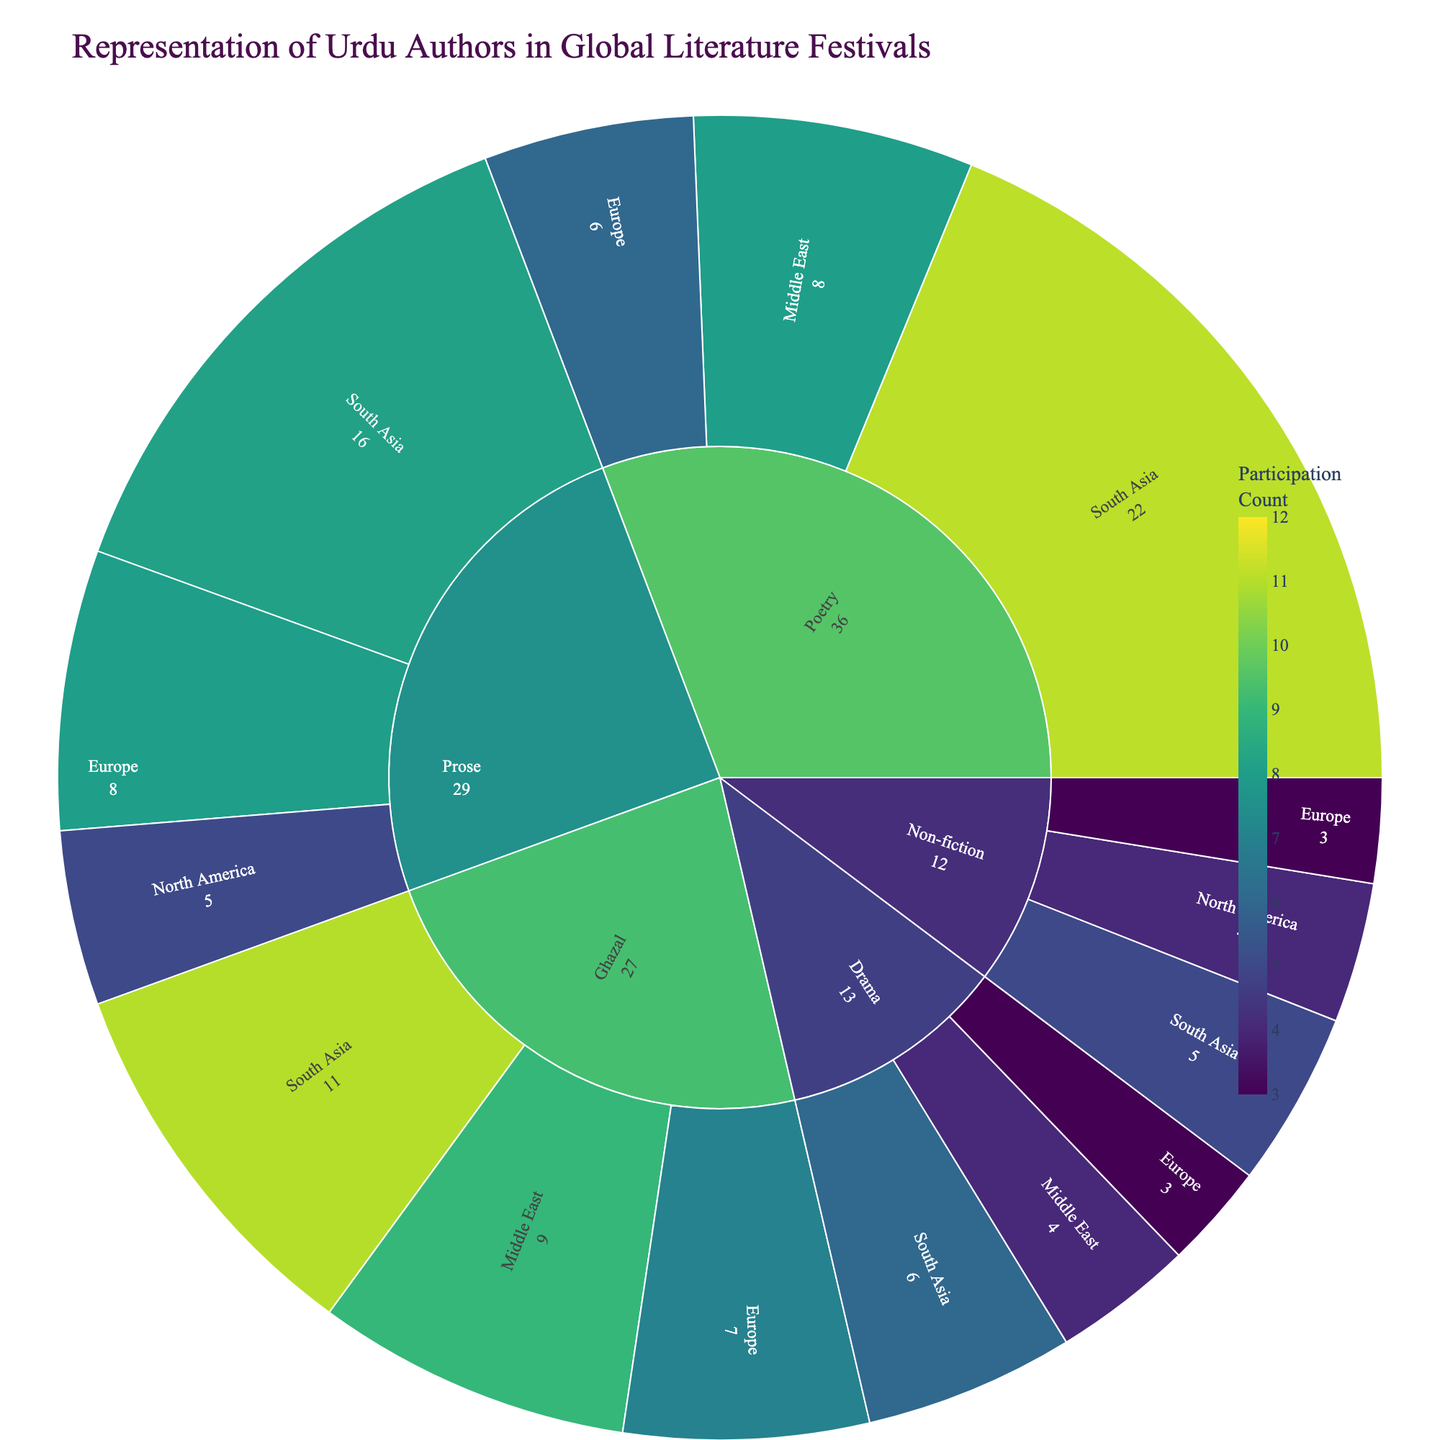How many genres are represented in the figure? The figure segments the authors by genre, region, and participation count. Just by observing the primary divisions of the Sunburst Plot, we can count the distinct segments that represent different genres.
Answer: 5 Which genre has the highest total participation count? To determine this, sum the participation counts of all authors within each genre. The genre with the highest sum is the one with the highest total participation count. Based on the data, Poetry has the highest total (36: Faiz Ahmed Faiz's 12 + Gulzar's 10 + Zehra Nigah's 8 + Parveen Shakir's 6).
Answer: Poetry Which region has the highest representation in the Ghazal genre? Focus on the segment for the Ghazal genre. Then, count the participation for each author segmented by region. South Asia (Mirza Ghalib with 11) has the highest representation in Ghazal compared to Middle East (Jaun Elia with 9) and Europe (Jigar Moradabadi with 7).
Answer: South Asia How does the participation of authors from South Asia in the Prose genre compare to those in the Poetry genre? Look at the total participation counts for authors in South Asia for both genres. In Prose, Qurratulain Hyder and Ismat Chughtai's counts sum to 16 (9 + 7). In Poetry, Faiz Ahmed Faiz and Gulzar's count sum to 22 (12 + 10). Therefore, Prose's participation is lower.
Answer: Prose: 16, Poetry: 22 What's the average participation count for authors in the Drama genre? Calculating the average involves summing the participation counts for all Drama authors and dividing by the number of authors in this genre. The counts are Munshi Premchand's 6, Agha Hashr Kashmiri's 4, and Rashid Jahan's 3. So (6 + 4 + 3) ÷ 3 = 13 ÷ 3 ≈ 4.33.
Answer: 4.33 Which author has the highest participation count within Europe? Focus on the Europe segments across all genres, noting the participation counts. Parveen Shakir (Poetry) with 6 has the highest count compared to Saadat Hasan Manto (Prose) with 8 and others.
Answer: Saadat Hasan Manto Is there more representation of authors in the Non-fiction genre in Europe or North America? Compare the sum of participation counts for Non-fiction authors in Europe (Qudsia Bano's 3) and North America (Syed Muhammad Latif's 4). North America has higher representation.
Answer: North America Which region has the smallest representation in the Drama genre? Compare the participation counts within the Drama genre for each region. Europe, with Rashid Jahan's 3, has the smallest representation in Drama compared to South Asia (Munshi Premchand's 6) and Middle East (Agha Hashr Kashmiri's 4).
Answer: Europe How many authors are represented in the Middle East across all genres? Count the distinct authors from the Middle East segments. There are Zehra Nigah (Poetry), Agha Hashr Kashmiri (Drama), and Jaun Elia (Ghazal), totaling three authors.
Answer: 3 